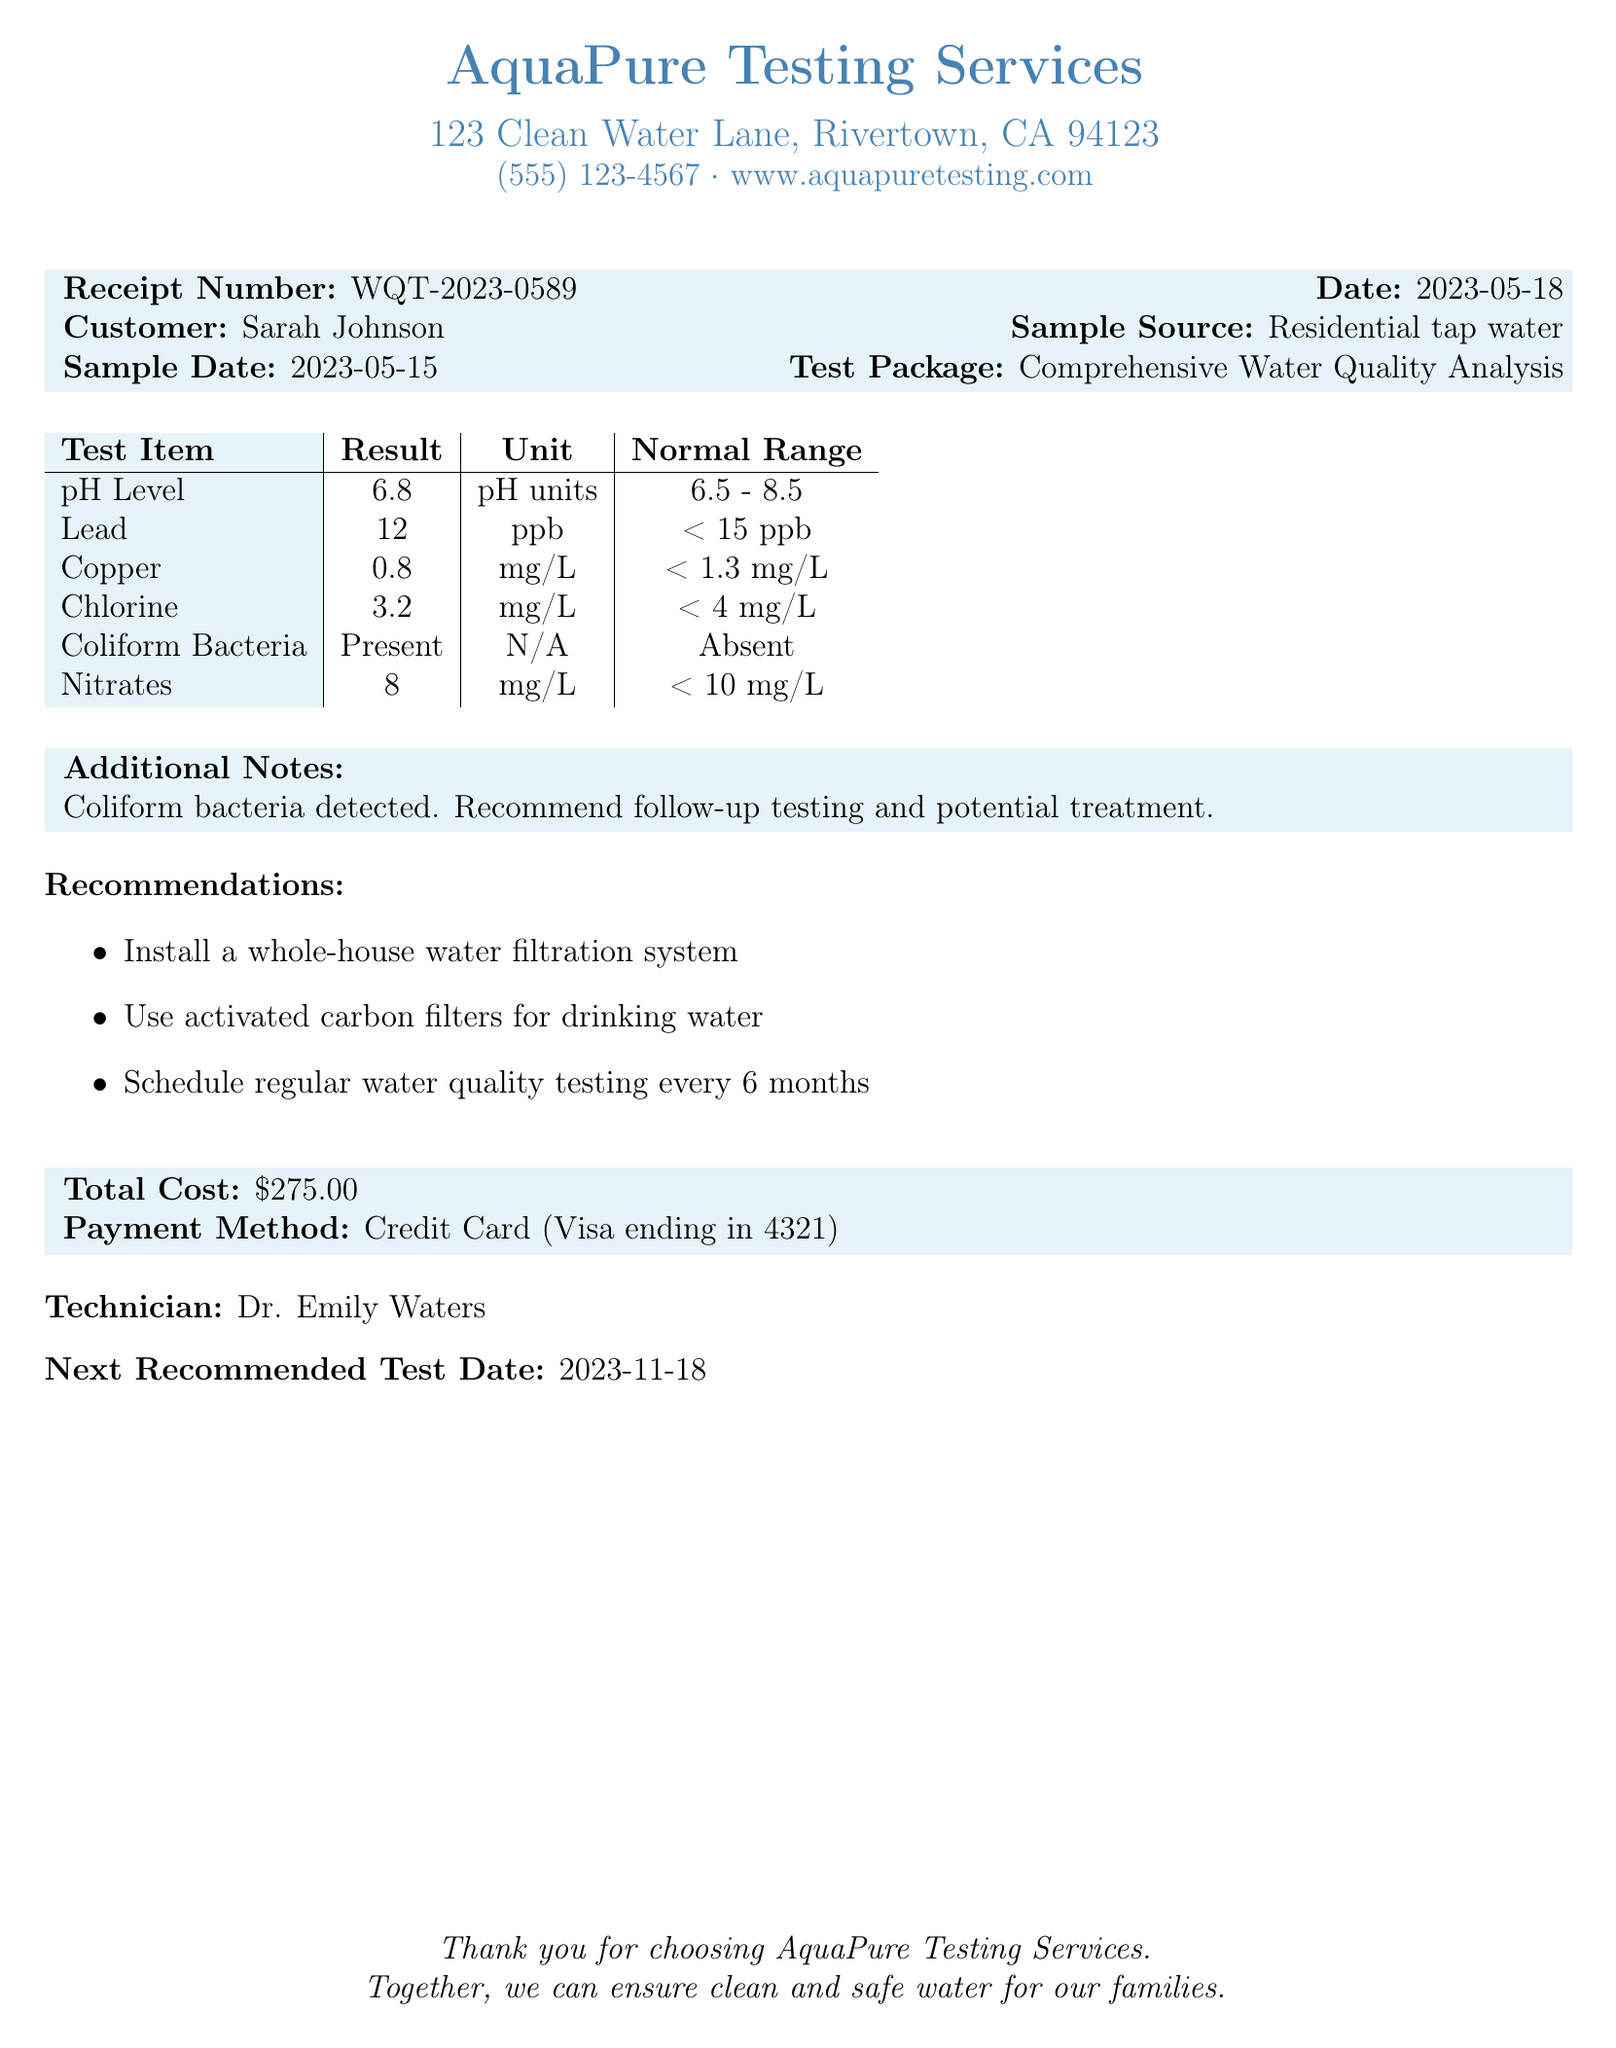What is the name of the laboratory? The name of the laboratory is provided at the top of the document.
Answer: AquaPure Testing Services What is the total cost of the water quality testing? The total cost section states the specific amount for the services rendered.
Answer: $275.00 What was the test item result for Lead? The result for the Lead test is found in the table of test items listed in the document.
Answer: 12 ppb Who conducted the analysis? The technician's name is mentioned towards the end of the document as responsible for the analysis.
Answer: Dr. Emily Waters When is the next recommended test date? The document provides a specific date under the recommendations for follow-up testing.
Answer: 2023-11-18 What was detected in the water sample? The additional notes section gives specific information regarding the finding from the water analysis.
Answer: Coliform bacteria What is the sample source of the water tested? The sample source is indicated in the receipt details provided in the initial section of the document.
Answer: Residential tap water What payment method was used? The payment method is mentioned in the section regarding the cost on the receipt.
Answer: Credit Card (Visa ending in 4321) What is the normal range for pH Level? The normal range for the pH Level is included in the results table in the document.
Answer: 6.5 - 8.5 